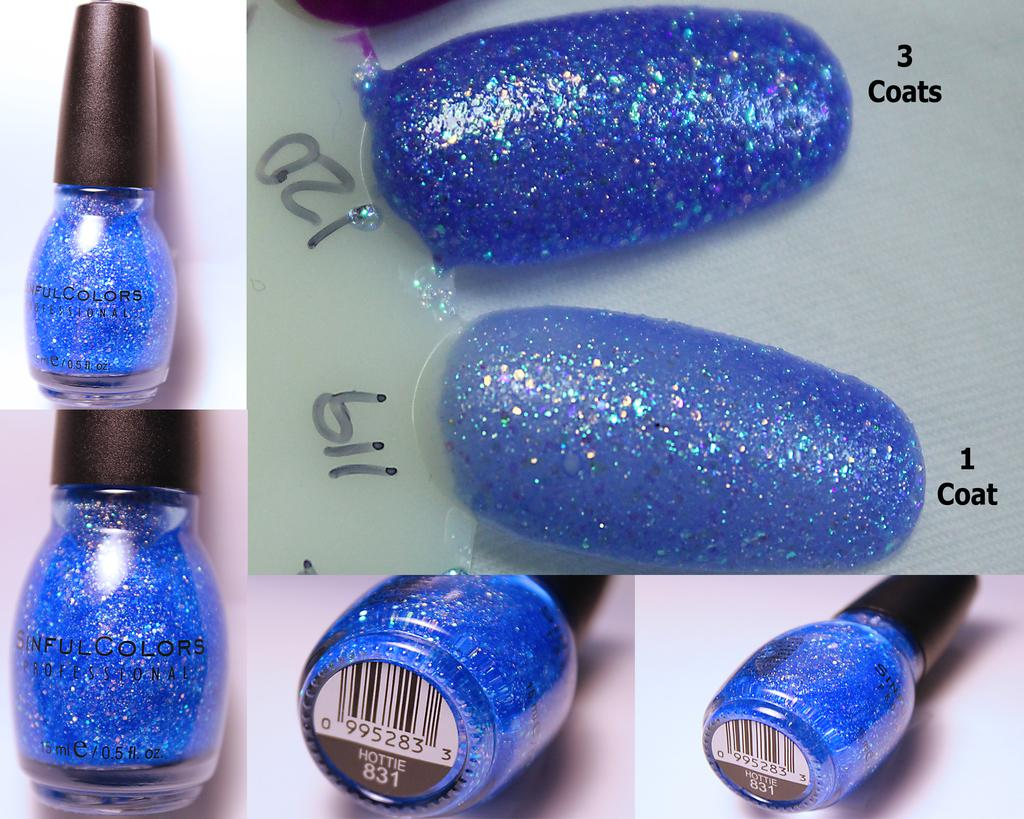What type of picture is in the image? There is a collage picture in the image. What objects are included in the collage picture? The collage picture contains a nail-polish bottle and two plastic nails. What color is on the plastic nails? The plastic nails have blue colored nail polish on them. How many brothers are depicted in the collage picture? There are no brothers depicted in the collage picture; it features a nail-polish bottle and plastic nails. What type of plants can be seen in the collage picture? There are no plants present in the collage picture; it features a nail-polish bottle and plastic nails. 